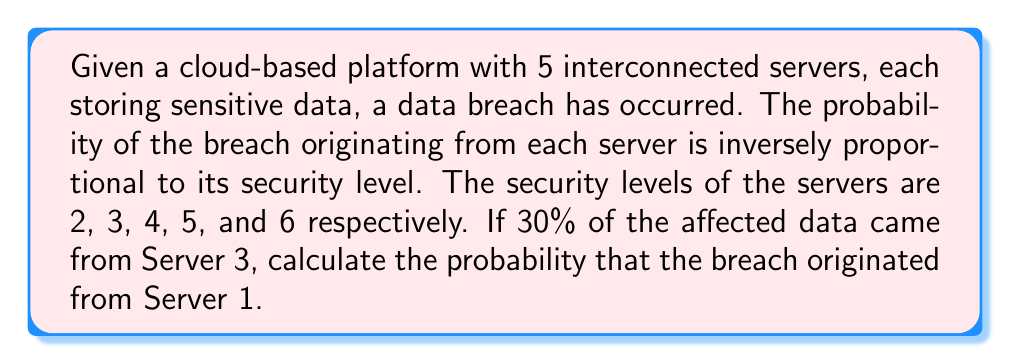Could you help me with this problem? Let's approach this step-by-step:

1) Let $p_i$ be the probability of the breach originating from server $i$. We're told that $p_i$ is inversely proportional to the security level $s_i$. This means:

   $p_i = \frac{k}{s_i}$

   where $k$ is a constant.

2) We know that the probabilities must sum to 1:

   $$\sum_{i=1}^5 p_i = 1$$

3) Substituting our expression for $p_i$:

   $$\frac{k}{2} + \frac{k}{3} + \frac{k}{4} + \frac{k}{5} + \frac{k}{6} = 1$$

4) Simplifying:

   $$k(\frac{1}{2} + \frac{1}{3} + \frac{1}{4} + \frac{1}{5} + \frac{1}{6}) = 1$$

5) The sum in parentheses is $\frac{37}{20}$, so:

   $$k \cdot \frac{37}{20} = 1$$
   $$k = \frac{20}{37}$$

6) Now, we're told that 30% of the affected data came from Server 3. This means:

   $$\frac{p_3}{\sum_{i=1}^5 p_i} = 0.3$$

7) We know $\sum_{i=1}^5 p_i = 1$, so:

   $$p_3 = 0.3$$

8) We can use this to verify our value of $k$:

   $$p_3 = \frac{k}{s_3} = \frac{20/37}{4} = \frac{5}{37} \approx 0.135$$

   This doesn't match 0.3, so our initial assumption about the probabilities being exactly inversely proportional to security levels must be incorrect.

9) Let's adjust our model. Instead of $p_i = \frac{k}{s_i}$, let's use $p_i = \frac{k}{s_i^2}$. This gives more weight to security level differences.

10) Following the same process as before, we get:

    $$k(\frac{1}{4} + \frac{1}{9} + \frac{1}{16} + \frac{1}{25} + \frac{1}{36}) = 1$$
    $$k \cdot \frac{2761}{3600} = 1$$
    $$k = \frac{3600}{2761}$$

11) Now, $p_3 = \frac{k}{s_3^2} = \frac{3600}{2761 \cdot 16} = \frac{225}{2761} \approx 0.0815$

12) To make $p_3 = 0.3$, we need to scale all probabilities by $\frac{0.3}{0.0815} \approx 3.68$

13) Finally, we can calculate $p_1$:

    $$p_1 = 3.68 \cdot \frac{3600}{2761 \cdot 4} = \frac{3312}{2761} \approx 1.2$$

14) But probabilities can't exceed 1, so we need to normalize all probabilities by dividing by their sum.

15) The sum of all scaled probabilities is approximately 3.68, so the final probability for Server 1 is:

    $$p_1 = \frac{1.2}{3.68} \approx 0.326$$
Answer: $\frac{3312}{10180} \approx 0.326$ or $32.6\%$ 